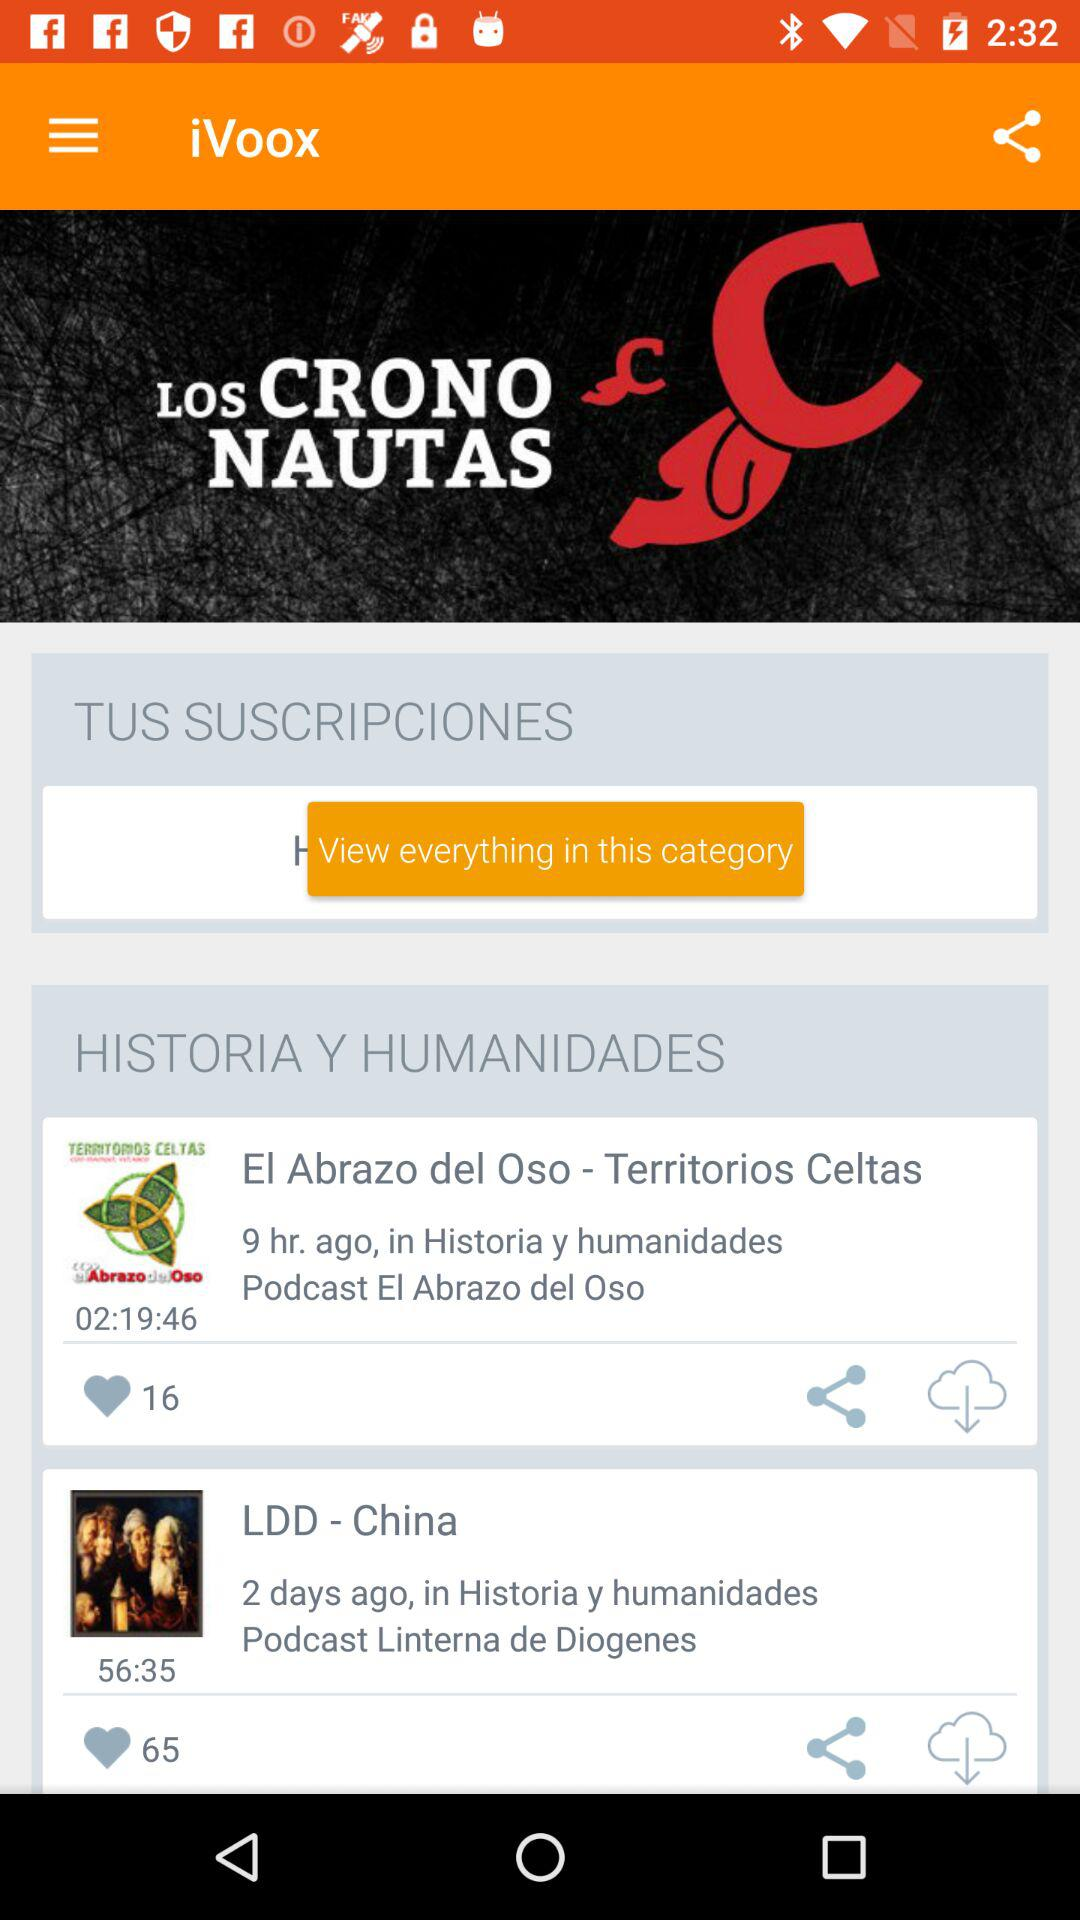How many more hearts does the second podcast have than the first?
Answer the question using a single word or phrase. 49 